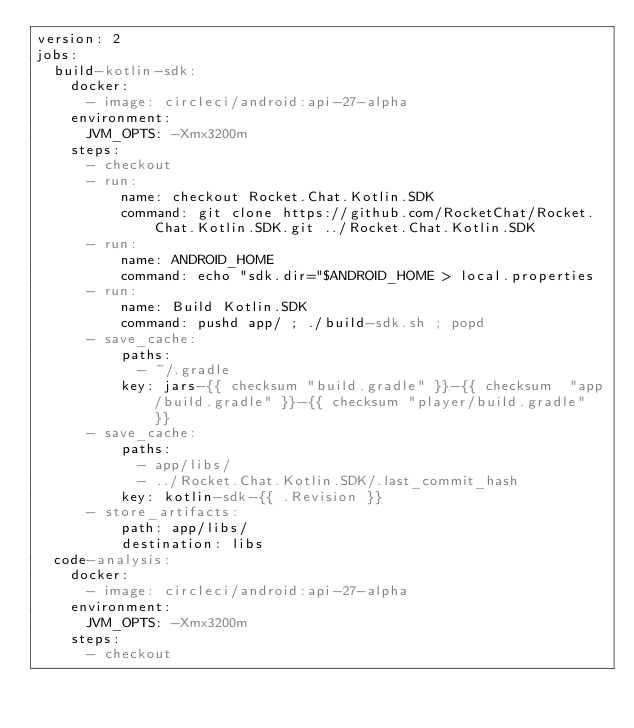<code> <loc_0><loc_0><loc_500><loc_500><_YAML_>version: 2
jobs:
  build-kotlin-sdk:
    docker:
      - image: circleci/android:api-27-alpha
    environment:
      JVM_OPTS: -Xmx3200m
    steps:
      - checkout
      - run:
          name: checkout Rocket.Chat.Kotlin.SDK
          command: git clone https://github.com/RocketChat/Rocket.Chat.Kotlin.SDK.git ../Rocket.Chat.Kotlin.SDK
      - run:
          name: ANDROID_HOME
          command: echo "sdk.dir="$ANDROID_HOME > local.properties 
      - run:
          name: Build Kotlin.SDK
          command: pushd app/ ; ./build-sdk.sh ; popd
      - save_cache:
          paths:
            - ~/.gradle
          key: jars-{{ checksum "build.gradle" }}-{{ checksum  "app/build.gradle" }}-{{ checksum "player/build.gradle" }}
      - save_cache:
          paths:
            - app/libs/
            - ../Rocket.Chat.Kotlin.SDK/.last_commit_hash
          key: kotlin-sdk-{{ .Revision }}
      - store_artifacts:
          path: app/libs/
          destination: libs
  code-analysis:
    docker:
      - image: circleci/android:api-27-alpha
    environment:
      JVM_OPTS: -Xmx3200m
    steps:
      - checkout</code> 